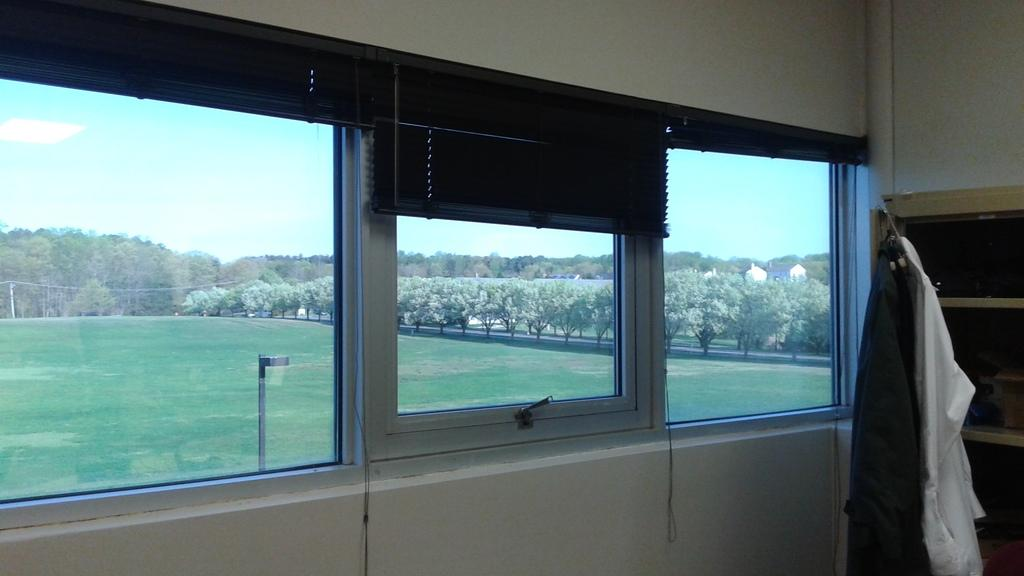What type of space is depicted in the image? There is a room in the image. What can be seen near the storage rack in the room? Clothes are hanged beside a storage rack in the room. How many windows are present in the room? There are three windows in the room. What is visible through the windows? A beautiful garden with plenty of trees is visible through the windows. How many kittens are playing with a knot in the mine visible through the windows? There are no kittens, knots, or mines visible through the windows. The image shows a beautiful garden with plenty of trees. 